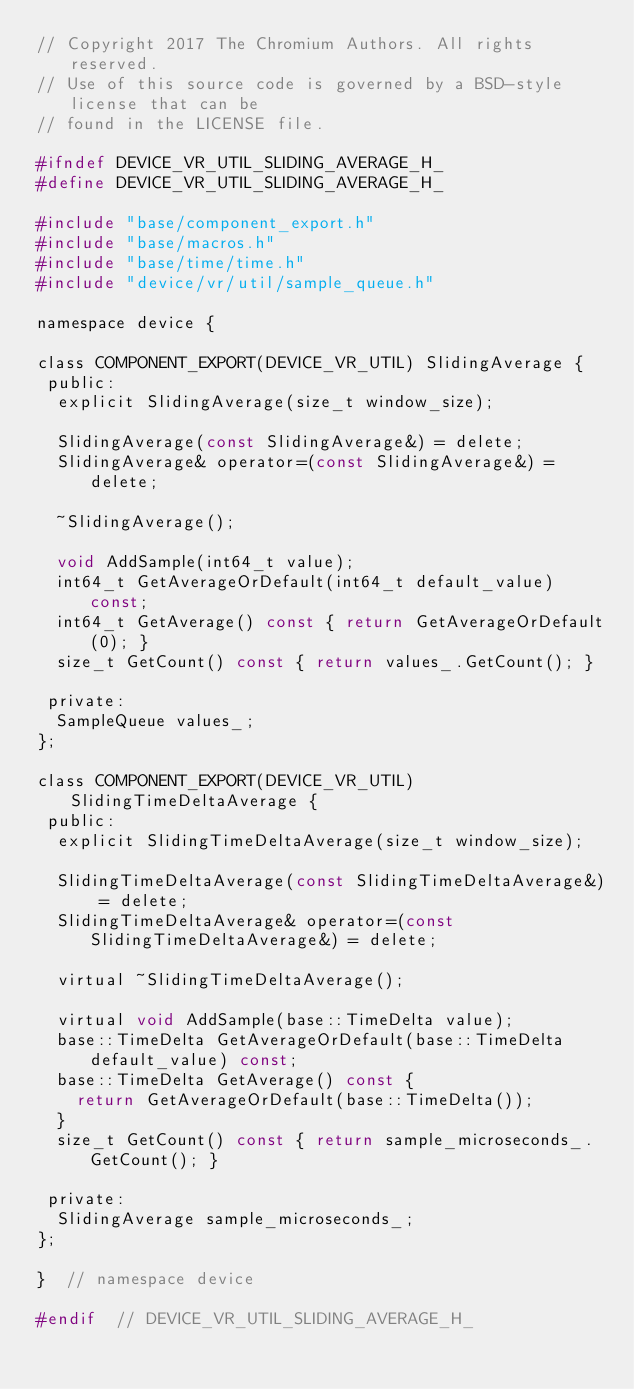<code> <loc_0><loc_0><loc_500><loc_500><_C_>// Copyright 2017 The Chromium Authors. All rights reserved.
// Use of this source code is governed by a BSD-style license that can be
// found in the LICENSE file.

#ifndef DEVICE_VR_UTIL_SLIDING_AVERAGE_H_
#define DEVICE_VR_UTIL_SLIDING_AVERAGE_H_

#include "base/component_export.h"
#include "base/macros.h"
#include "base/time/time.h"
#include "device/vr/util/sample_queue.h"

namespace device {

class COMPONENT_EXPORT(DEVICE_VR_UTIL) SlidingAverage {
 public:
  explicit SlidingAverage(size_t window_size);

  SlidingAverage(const SlidingAverage&) = delete;
  SlidingAverage& operator=(const SlidingAverage&) = delete;

  ~SlidingAverage();

  void AddSample(int64_t value);
  int64_t GetAverageOrDefault(int64_t default_value) const;
  int64_t GetAverage() const { return GetAverageOrDefault(0); }
  size_t GetCount() const { return values_.GetCount(); }

 private:
  SampleQueue values_;
};

class COMPONENT_EXPORT(DEVICE_VR_UTIL) SlidingTimeDeltaAverage {
 public:
  explicit SlidingTimeDeltaAverage(size_t window_size);

  SlidingTimeDeltaAverage(const SlidingTimeDeltaAverage&) = delete;
  SlidingTimeDeltaAverage& operator=(const SlidingTimeDeltaAverage&) = delete;

  virtual ~SlidingTimeDeltaAverage();

  virtual void AddSample(base::TimeDelta value);
  base::TimeDelta GetAverageOrDefault(base::TimeDelta default_value) const;
  base::TimeDelta GetAverage() const {
    return GetAverageOrDefault(base::TimeDelta());
  }
  size_t GetCount() const { return sample_microseconds_.GetCount(); }

 private:
  SlidingAverage sample_microseconds_;
};

}  // namespace device

#endif  // DEVICE_VR_UTIL_SLIDING_AVERAGE_H_
</code> 